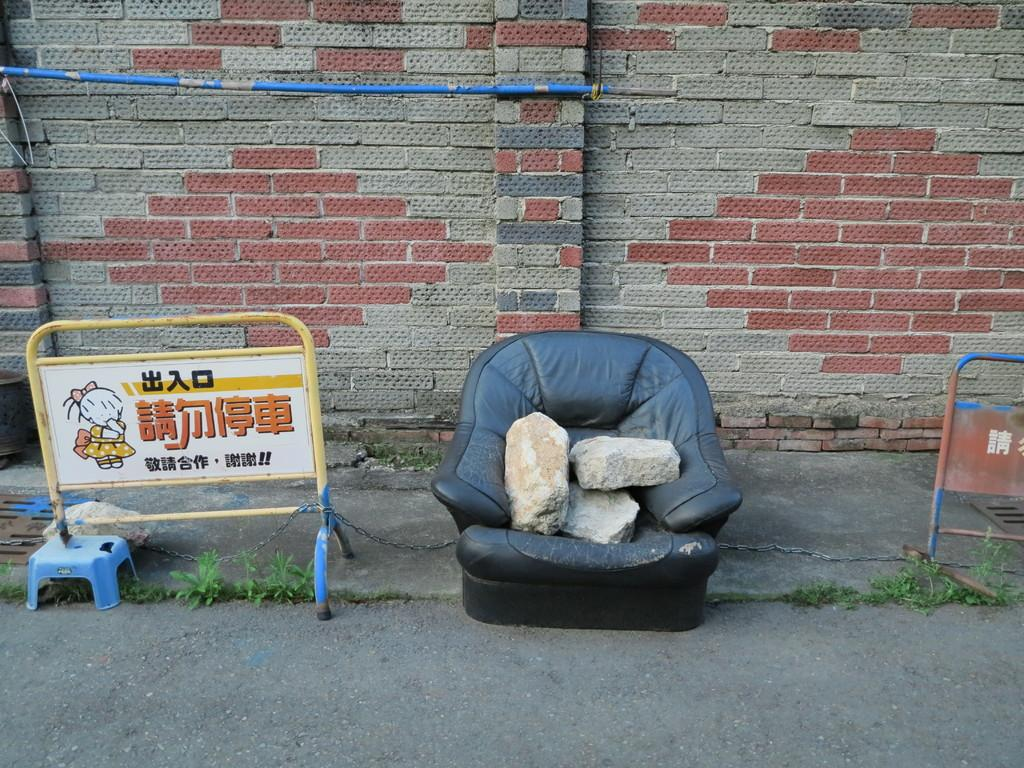What can be seen blocking or dividing the area in the image? There are barricades in the image. What type of vegetation is present on both sides of the image? There are small plants on both sides of the image. What is placed on the sofa in the center of the image? There are stones on a sofa in the center of the image. What can be seen in the background of the image? There is a pipe and a wall in the background of the image. What type of soup is being served in the image? There is no soup present in the image. Can you see any insects crawling on the barricades in the image? There are no insects visible in the image. 